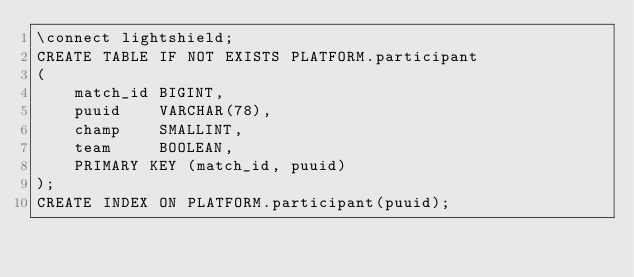Convert code to text. <code><loc_0><loc_0><loc_500><loc_500><_SQL_>\connect lightshield;
CREATE TABLE IF NOT EXISTS PLATFORM.participant
(
    match_id BIGINT,
    puuid    VARCHAR(78),
    champ    SMALLINT,
    team     BOOLEAN,
    PRIMARY KEY (match_id, puuid)
);
CREATE INDEX ON PLATFORM.participant(puuid);
</code> 